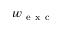<formula> <loc_0><loc_0><loc_500><loc_500>w _ { e x c }</formula> 